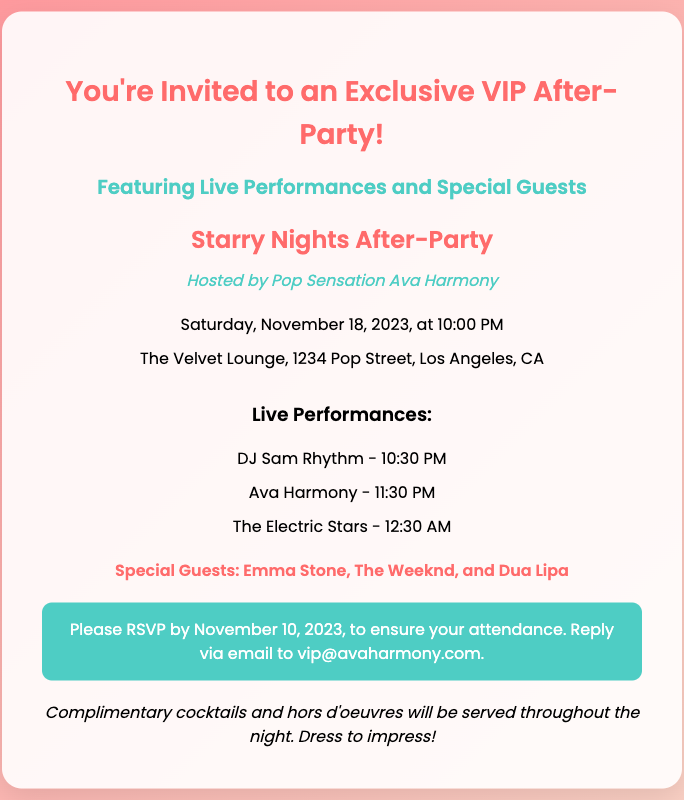What is the event name? The event name is stated in the event details section as "Starry Nights After-Party."
Answer: Starry Nights After-Party Who is hosting the event? The host name is mentioned in the document, indicating who will be hosting the party.
Answer: Pop Sensation Ava Harmony What is the date of the After-Party? The date and time of the event are provided in the event details section, which includes the specific date.
Answer: Saturday, November 18, 2023 Where is the venue located? The venue address is listed in the event details, providing the specific location of the After-Party.
Answer: The Velvet Lounge, 1234 Pop Street, Los Angeles, CA What time does DJ Sam Rhythm perform? The schedule of performances includes the specific performance time for DJ Sam Rhythm.
Answer: 10:30 PM Who are the special guests? The special guests are listed in the document and can be referenced for who will be attending.
Answer: Emma Stone, The Weeknd, and Dua Lipa When is the RSVP deadline? The RSVP instructions section provides a specific date by which attendees should respond to the invitation.
Answer: November 10, 2023 What is provided throughout the night? The additional info section indicates what refreshments will be available to attendees.
Answer: Complimentary cocktails and hors d'oeuvres What should attendees wear? The additional info section gives a directive on dress expectations for the event.
Answer: Dress to impress! 